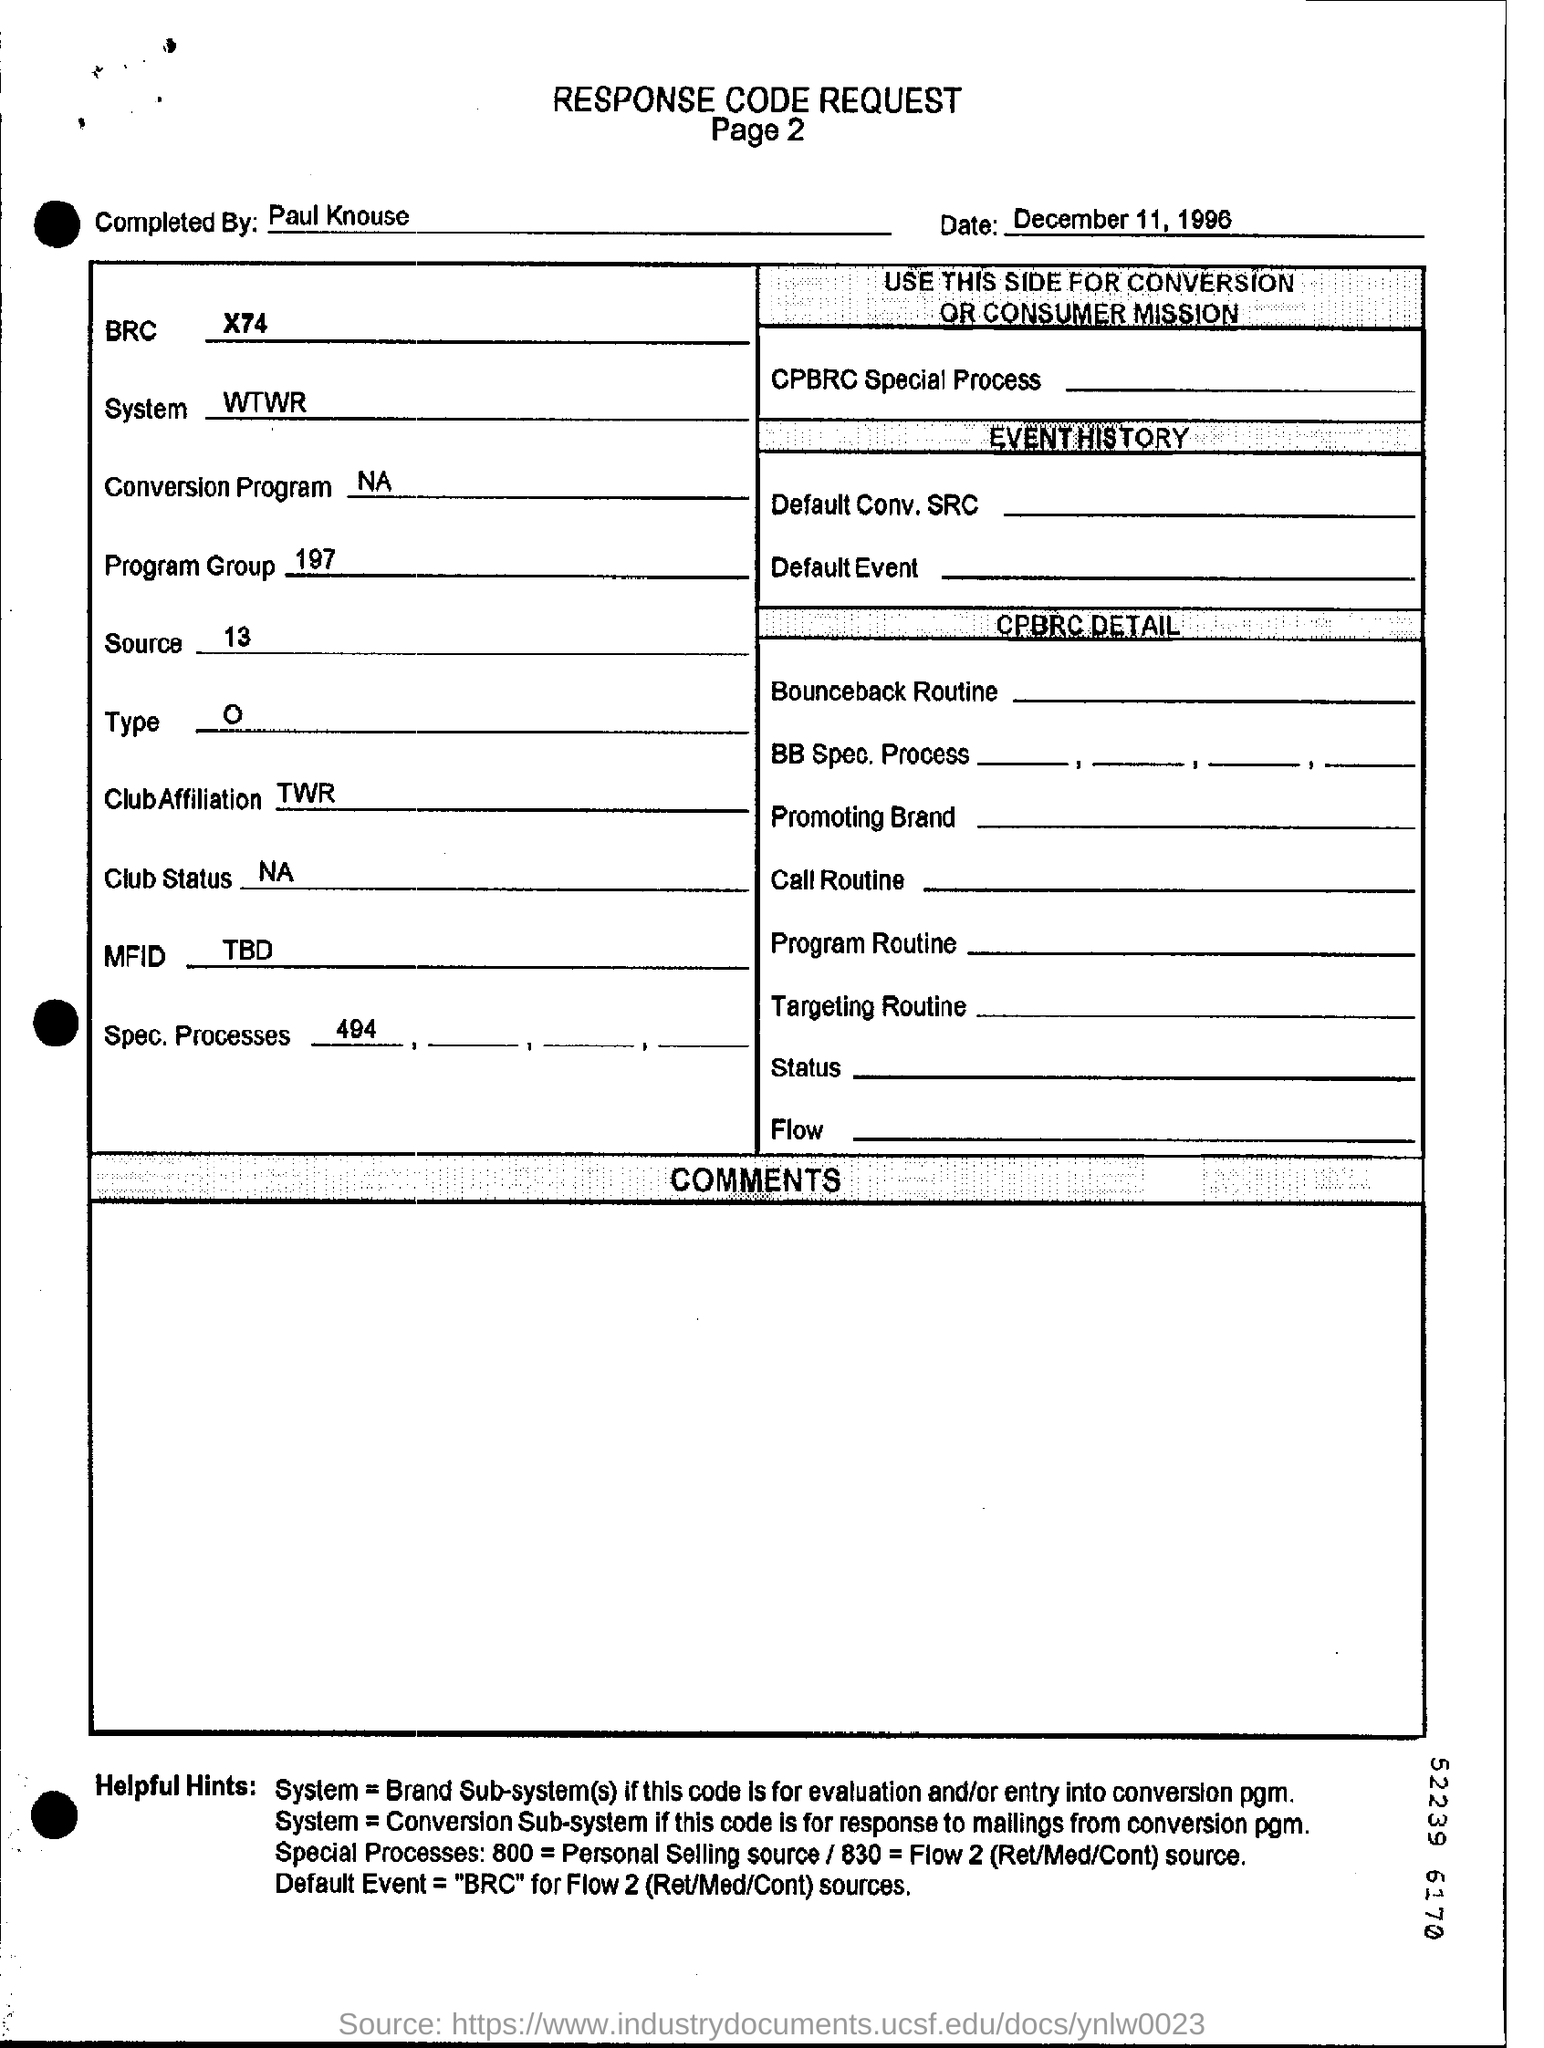Draw attention to some important aspects in this diagram. The date of the request form is December 11, 1996. 